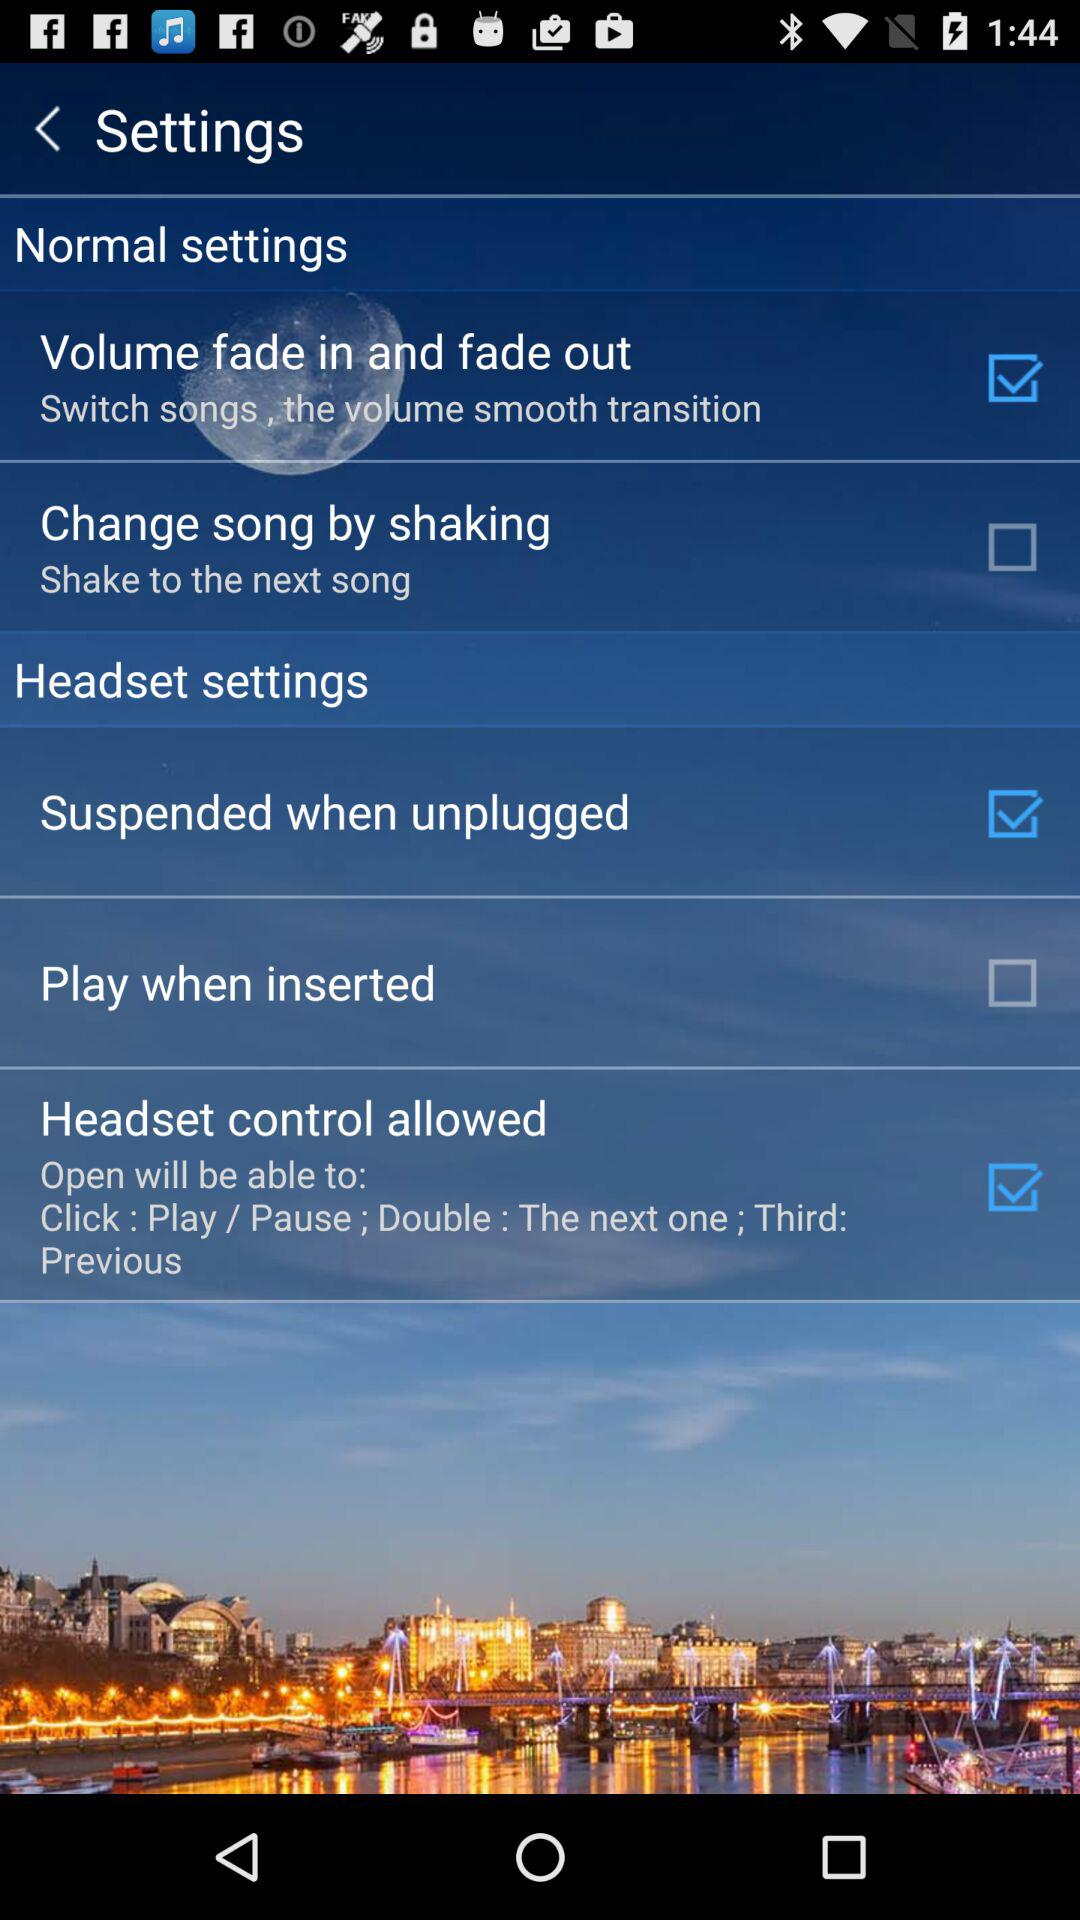What is the status of the "Volume fade in and fade out" setting? The status is "on". 